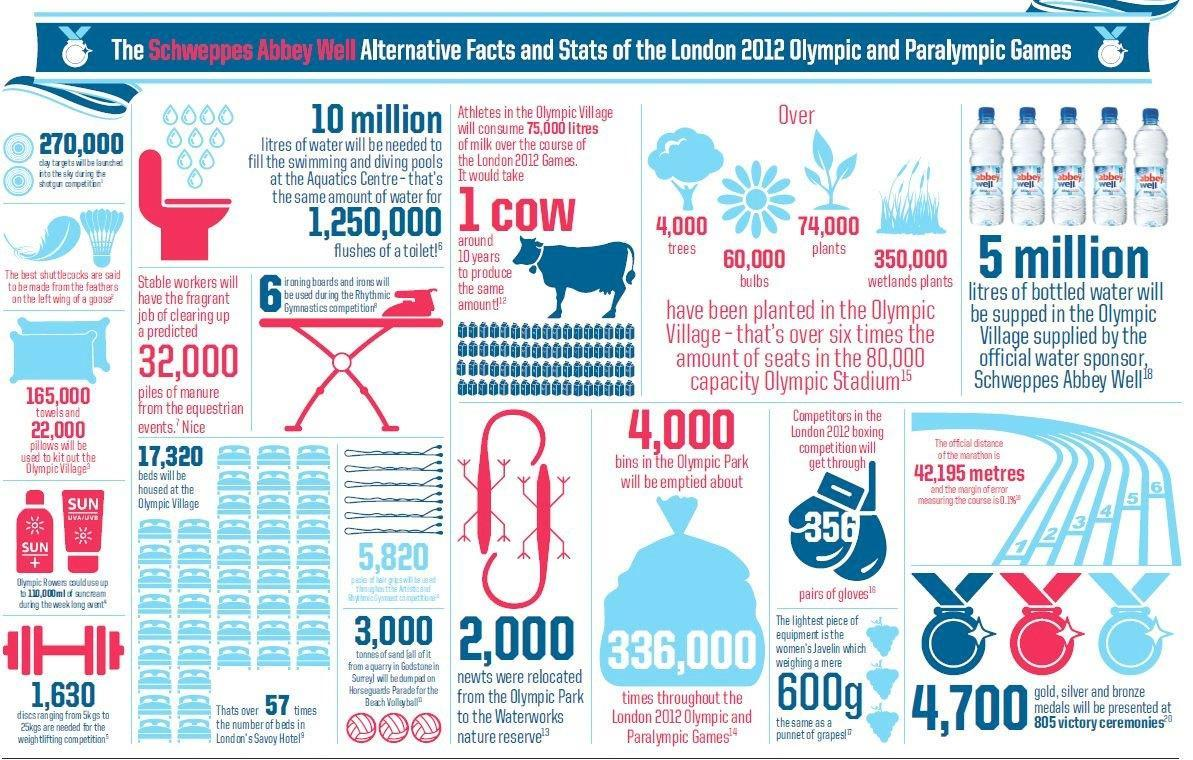At which place was 74,000 plants planted?
Answer the question with a short phrase. Olympic village Who is the official water sponsor for Olympic village? Schweppes Abbey Well 2000 newts were relocated to which place? Waterworks nature reserve How much milk will be consumed by athletes at Olympic Village? 75,000 litres What will Schweppes Abbey Well supply? bottled water How many litres of water is equivalent to 1,250,000 flushes of a toilet? 10 million How many piles of manure will have to be cleared by stable workers? 32,000 How many trees were planted in the Olympic village? 4,000 How many years could it take for a cow to produce 75,000 litres of milk? 10 years At which event location of Olympic games is 10 million litres of water required? Aquatic Centre 